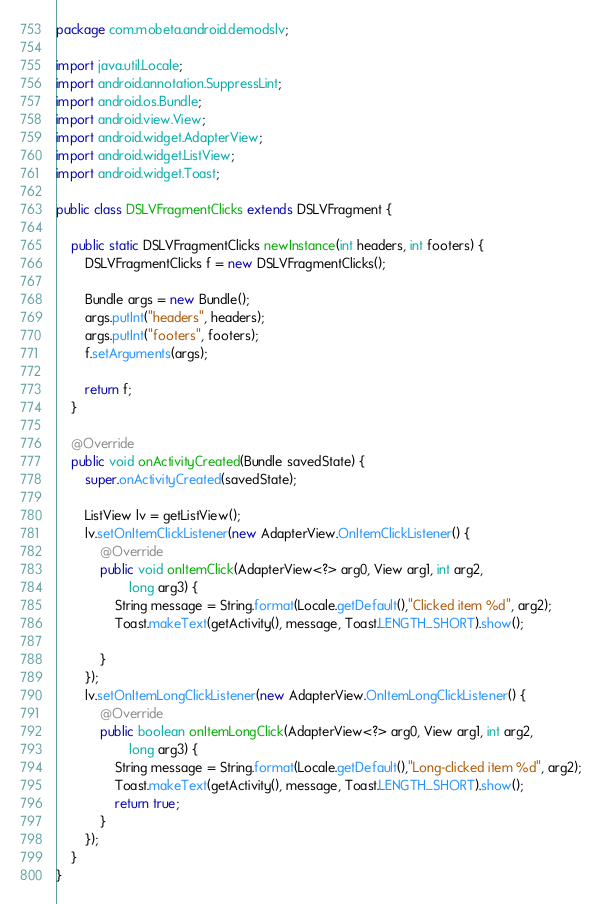Convert code to text. <code><loc_0><loc_0><loc_500><loc_500><_Java_>package com.mobeta.android.demodslv;

import java.util.Locale;
import android.annotation.SuppressLint;
import android.os.Bundle;
import android.view.View;
import android.widget.AdapterView;
import android.widget.ListView;
import android.widget.Toast;

public class DSLVFragmentClicks extends DSLVFragment {

    public static DSLVFragmentClicks newInstance(int headers, int footers) {
        DSLVFragmentClicks f = new DSLVFragmentClicks();

        Bundle args = new Bundle();
        args.putInt("headers", headers);
        args.putInt("footers", footers);
        f.setArguments(args);

        return f;
    }

	@Override
    public void onActivityCreated(Bundle savedState) {
        super.onActivityCreated(savedState);

        ListView lv = getListView();
        lv.setOnItemClickListener(new AdapterView.OnItemClickListener() {
			@Override
            public void onItemClick(AdapterView<?> arg0, View arg1, int arg2,
                    long arg3) {
                String message = String.format(Locale.getDefault(),"Clicked item %d", arg2);
                Toast.makeText(getActivity(), message, Toast.LENGTH_SHORT).show();
                
            }
        });
        lv.setOnItemLongClickListener(new AdapterView.OnItemLongClickListener() {
			@Override
            public boolean onItemLongClick(AdapterView<?> arg0, View arg1, int arg2,
                    long arg3) {
                String message = String.format(Locale.getDefault(),"Long-clicked item %d", arg2);
                Toast.makeText(getActivity(), message, Toast.LENGTH_SHORT).show();
                return true;
            }
        });
    }
}
</code> 